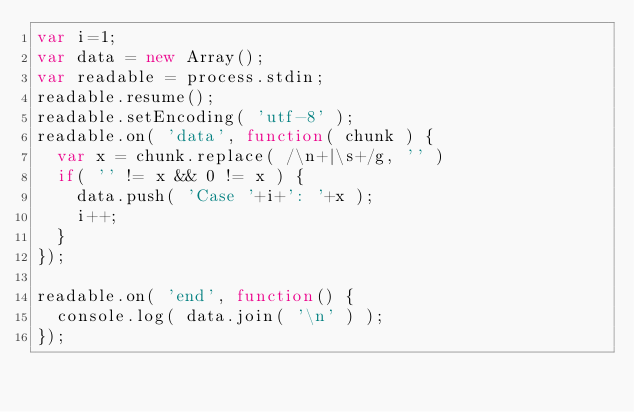Convert code to text. <code><loc_0><loc_0><loc_500><loc_500><_JavaScript_>var i=1;
var data = new Array();
var readable = process.stdin;
readable.resume();
readable.setEncoding( 'utf-8' );
readable.on( 'data', function( chunk ) {
  var x = chunk.replace( /\n+|\s+/g, '' )
  if( '' != x && 0 != x ) {
    data.push( 'Case '+i+': '+x );
    i++;
  }
});

readable.on( 'end', function() {
  console.log( data.join( '\n' ) );
});</code> 